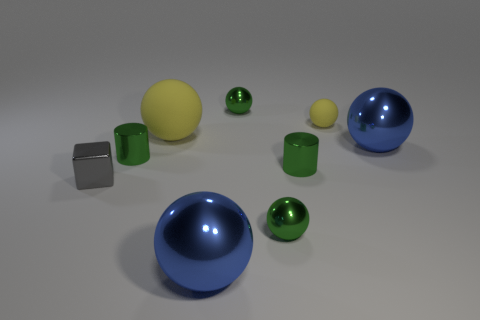Subtract all big blue metallic balls. How many balls are left? 4 Subtract all blue spheres. How many spheres are left? 4 Subtract all cyan spheres. Subtract all yellow cubes. How many spheres are left? 6 Subtract all cylinders. How many objects are left? 7 Add 4 metal cylinders. How many metal cylinders exist? 6 Subtract 0 yellow cubes. How many objects are left? 9 Subtract all tiny cylinders. Subtract all tiny green shiny cylinders. How many objects are left? 5 Add 7 small green shiny cylinders. How many small green shiny cylinders are left? 9 